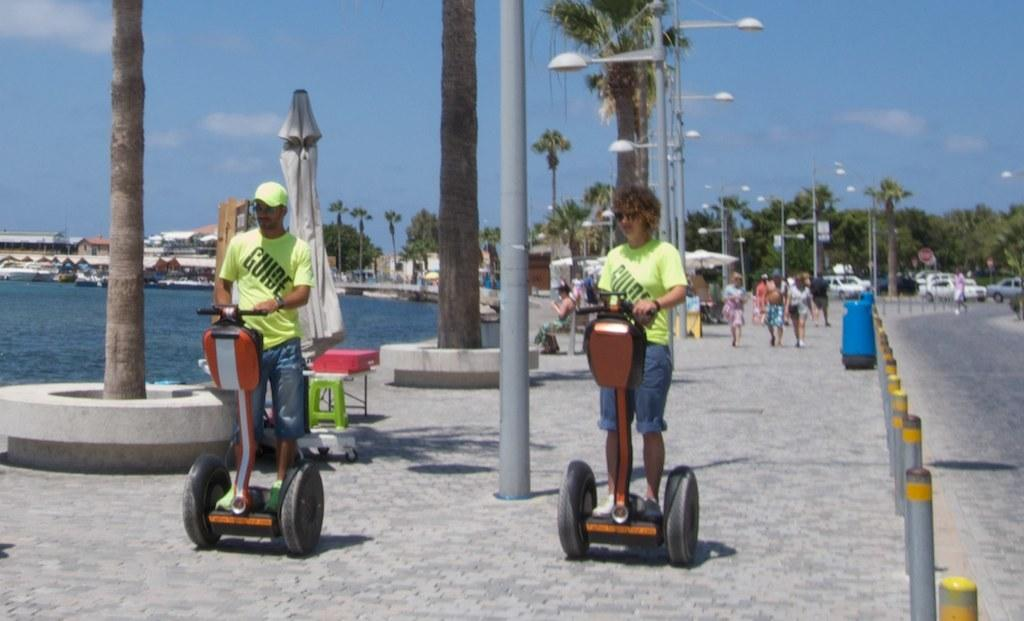What can be seen in the image? There are people, dustbins, street lamps, trees, cars, buildings, and the sky visible in the image. Can you describe the environment in the image? The image shows an urban setting with people, cars, buildings, and street lamps. There are also trees and dustbins present. What is the purpose of the street lamps in the image? The street lamps provide light in the urban setting, making it easier for people to see and navigate at night. How many cars are visible in the image? There are cars present in the image, but the exact number cannot be determined from the provided facts. Where is the hen located in the image? There is no hen present in the image. What type of calendar is hanging on the wall in the image? There is no calendar visible in the image. 